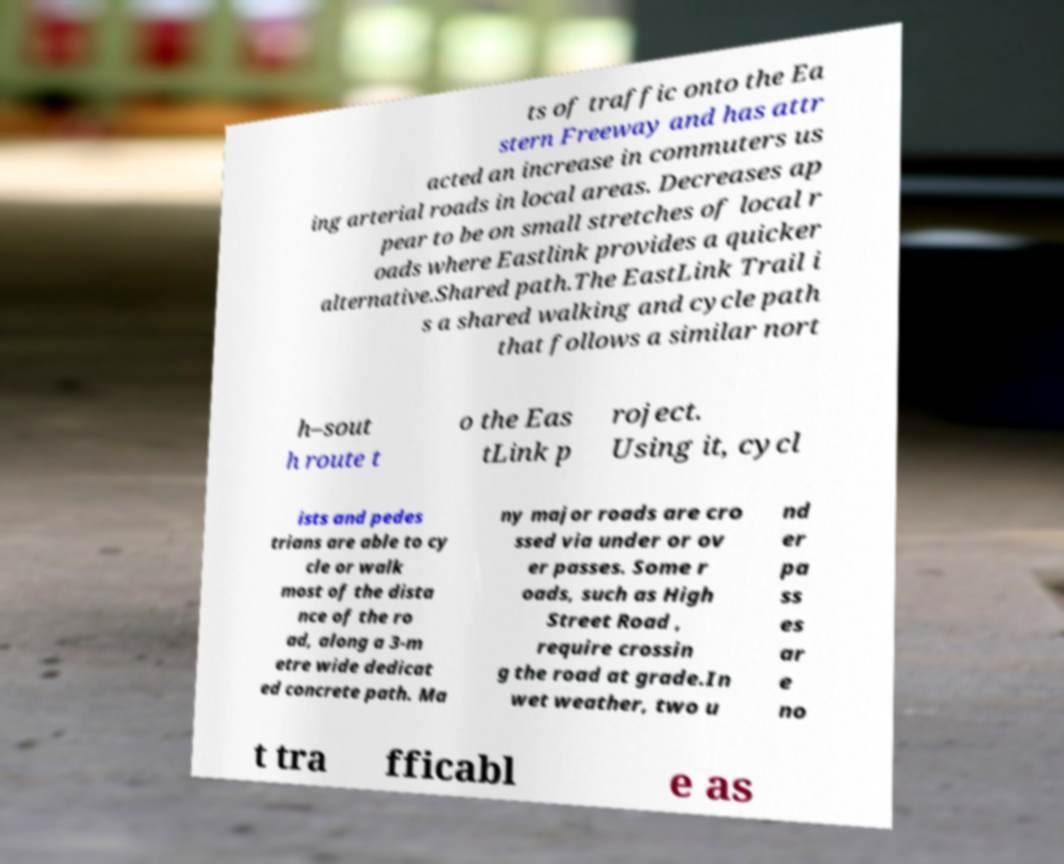Please identify and transcribe the text found in this image. ts of traffic onto the Ea stern Freeway and has attr acted an increase in commuters us ing arterial roads in local areas. Decreases ap pear to be on small stretches of local r oads where Eastlink provides a quicker alternative.Shared path.The EastLink Trail i s a shared walking and cycle path that follows a similar nort h–sout h route t o the Eas tLink p roject. Using it, cycl ists and pedes trians are able to cy cle or walk most of the dista nce of the ro ad, along a 3-m etre wide dedicat ed concrete path. Ma ny major roads are cro ssed via under or ov er passes. Some r oads, such as High Street Road , require crossin g the road at grade.In wet weather, two u nd er pa ss es ar e no t tra fficabl e as 